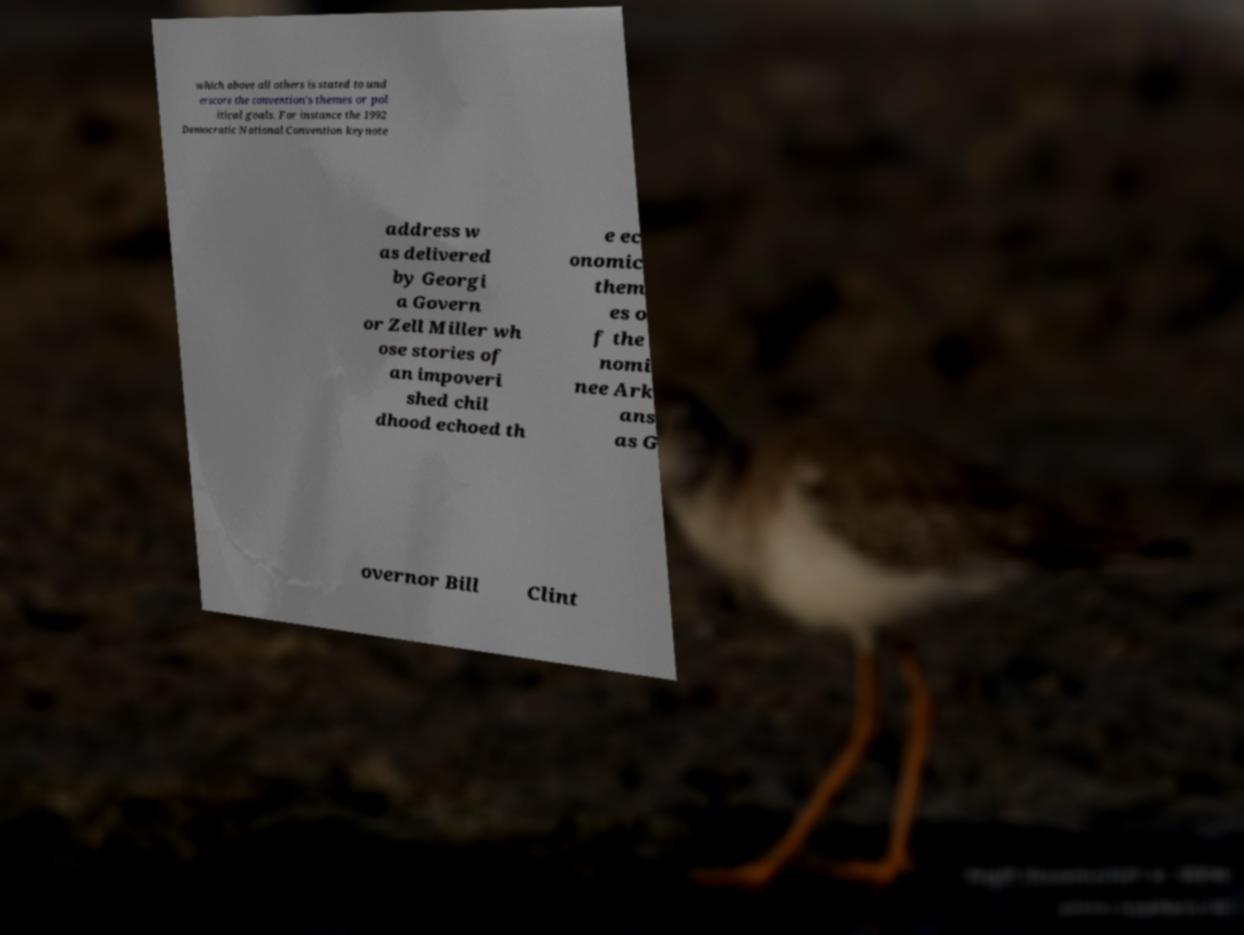Please read and relay the text visible in this image. What does it say? which above all others is stated to und erscore the convention's themes or pol itical goals. For instance the 1992 Democratic National Convention keynote address w as delivered by Georgi a Govern or Zell Miller wh ose stories of an impoveri shed chil dhood echoed th e ec onomic them es o f the nomi nee Ark ans as G overnor Bill Clint 